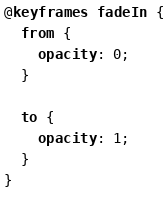<code> <loc_0><loc_0><loc_500><loc_500><_CSS_>@keyframes fadeIn {
  from {
    opacity: 0;
  }

  to {
    opacity: 1;
  }
}
</code> 